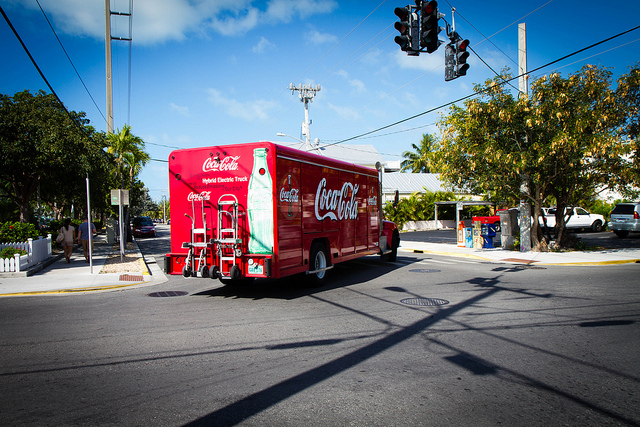Extract all visible text content from this image. CocaCola CocaCola CocaCola 